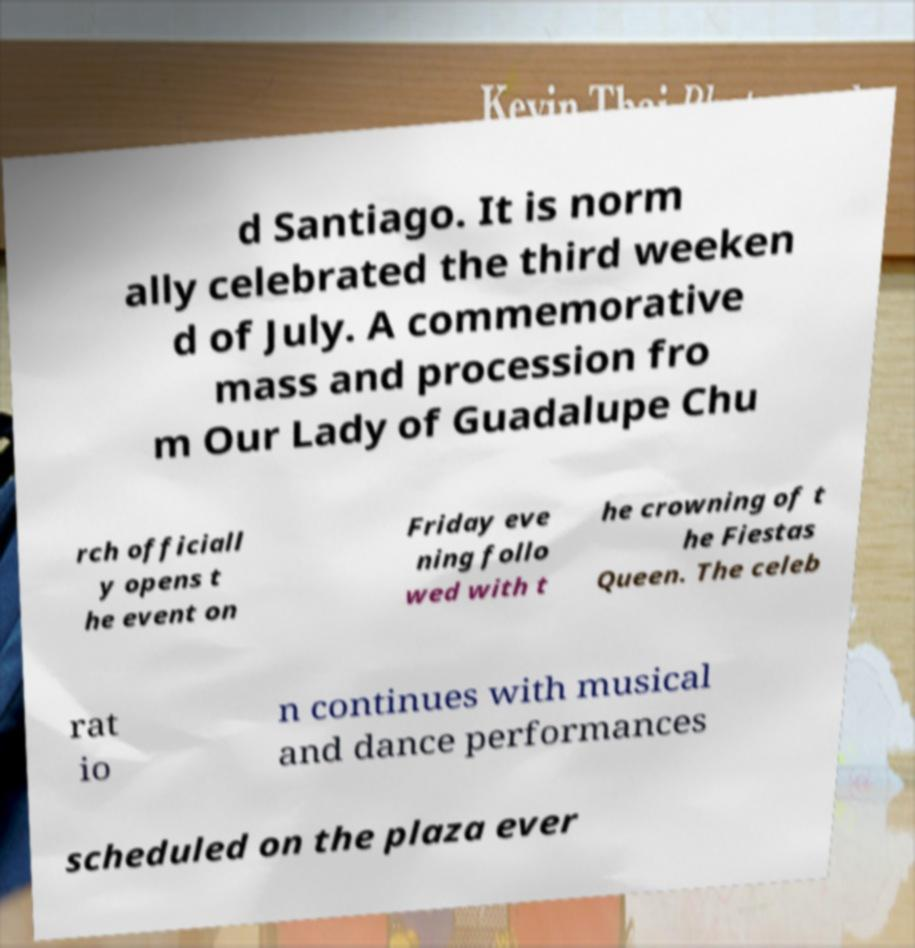I need the written content from this picture converted into text. Can you do that? d Santiago. It is norm ally celebrated the third weeken d of July. A commemorative mass and procession fro m Our Lady of Guadalupe Chu rch officiall y opens t he event on Friday eve ning follo wed with t he crowning of t he Fiestas Queen. The celeb rat io n continues with musical and dance performances scheduled on the plaza ever 